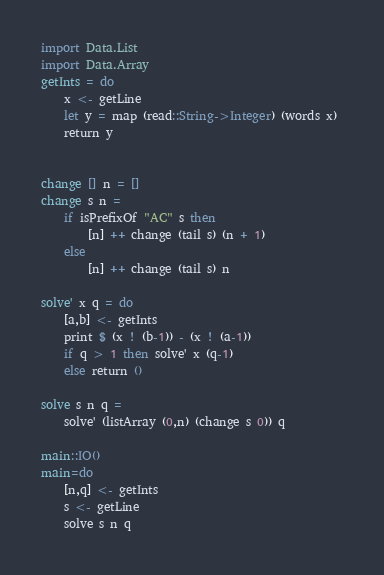Convert code to text. <code><loc_0><loc_0><loc_500><loc_500><_Haskell_>import Data.List
import Data.Array
getInts = do
    x <- getLine
    let y = map (read::String->Integer) (words x) 
    return y


change [] n = []
change s n = 
    if isPrefixOf "AC" s then 
        [n] ++ change (tail s) (n + 1)
    else 
        [n] ++ change (tail s) n

solve' x q = do
    [a,b] <- getInts
    print $ (x ! (b-1)) - (x ! (a-1))
    if q > 1 then solve' x (q-1)
    else return ()

solve s n q = 
    solve' (listArray (0,n) (change s 0)) q

main::IO()
main=do
    [n,q] <- getInts
    s <- getLine
    solve s n q
</code> 